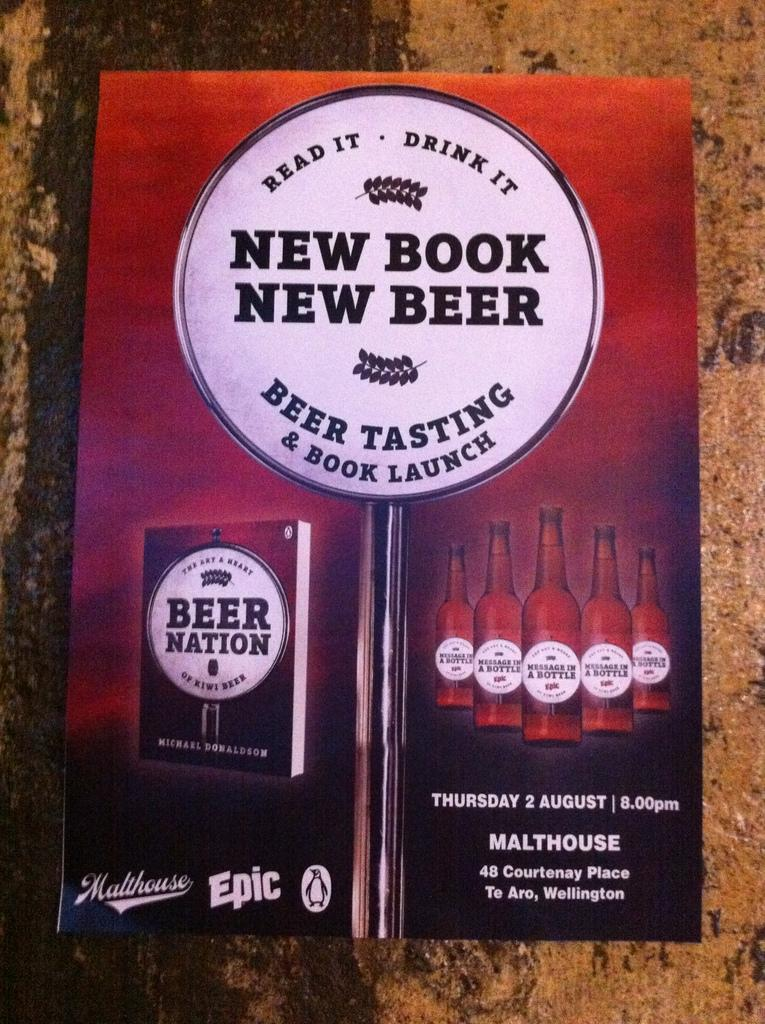<image>
Summarize the visual content of the image. A sign about New Book New Beer is hanging on a wall. 